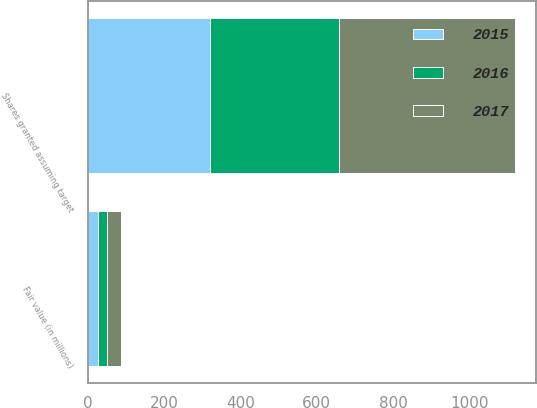Convert chart to OTSL. <chart><loc_0><loc_0><loc_500><loc_500><stacked_bar_chart><ecel><fcel>Shares granted assuming target<fcel>Fair value (in millions)<nl><fcel>2017<fcel>461<fcel>37<nl><fcel>2016<fcel>338<fcel>25<nl><fcel>2015<fcel>321<fcel>26<nl></chart> 